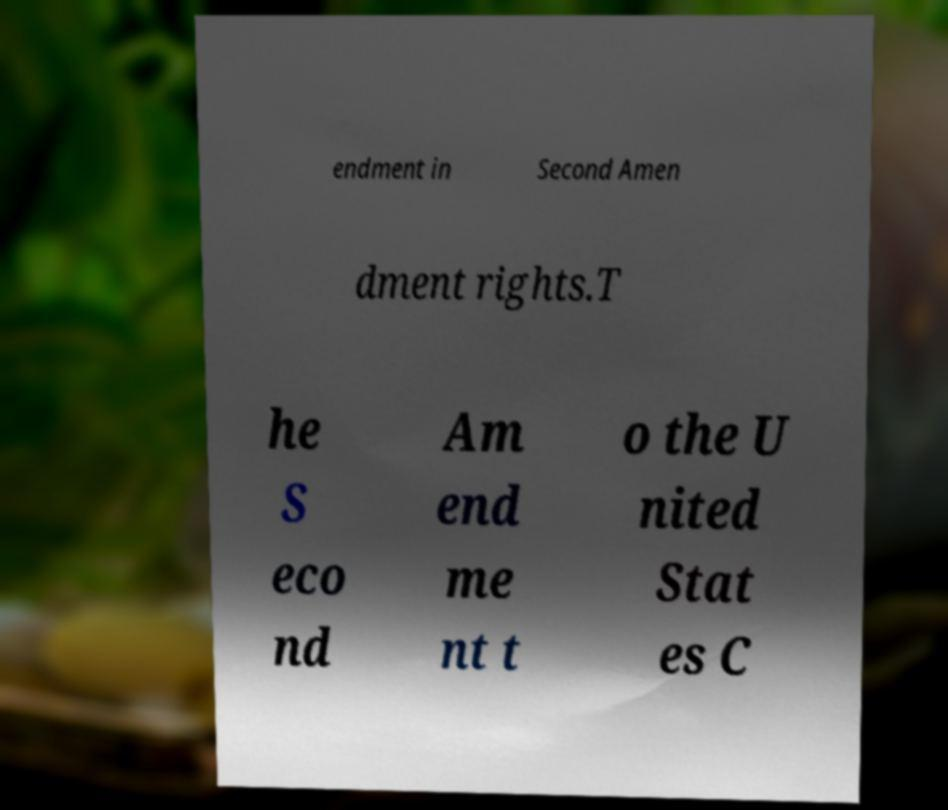Please identify and transcribe the text found in this image. endment in Second Amen dment rights.T he S eco nd Am end me nt t o the U nited Stat es C 